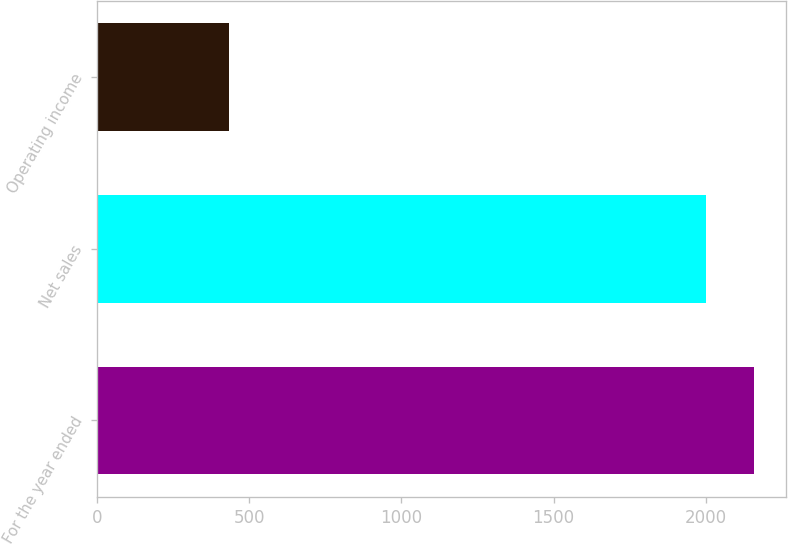Convert chart to OTSL. <chart><loc_0><loc_0><loc_500><loc_500><bar_chart><fcel>For the year ended<fcel>Net sales<fcel>Operating income<nl><fcel>2157<fcel>1999<fcel>435<nl></chart> 